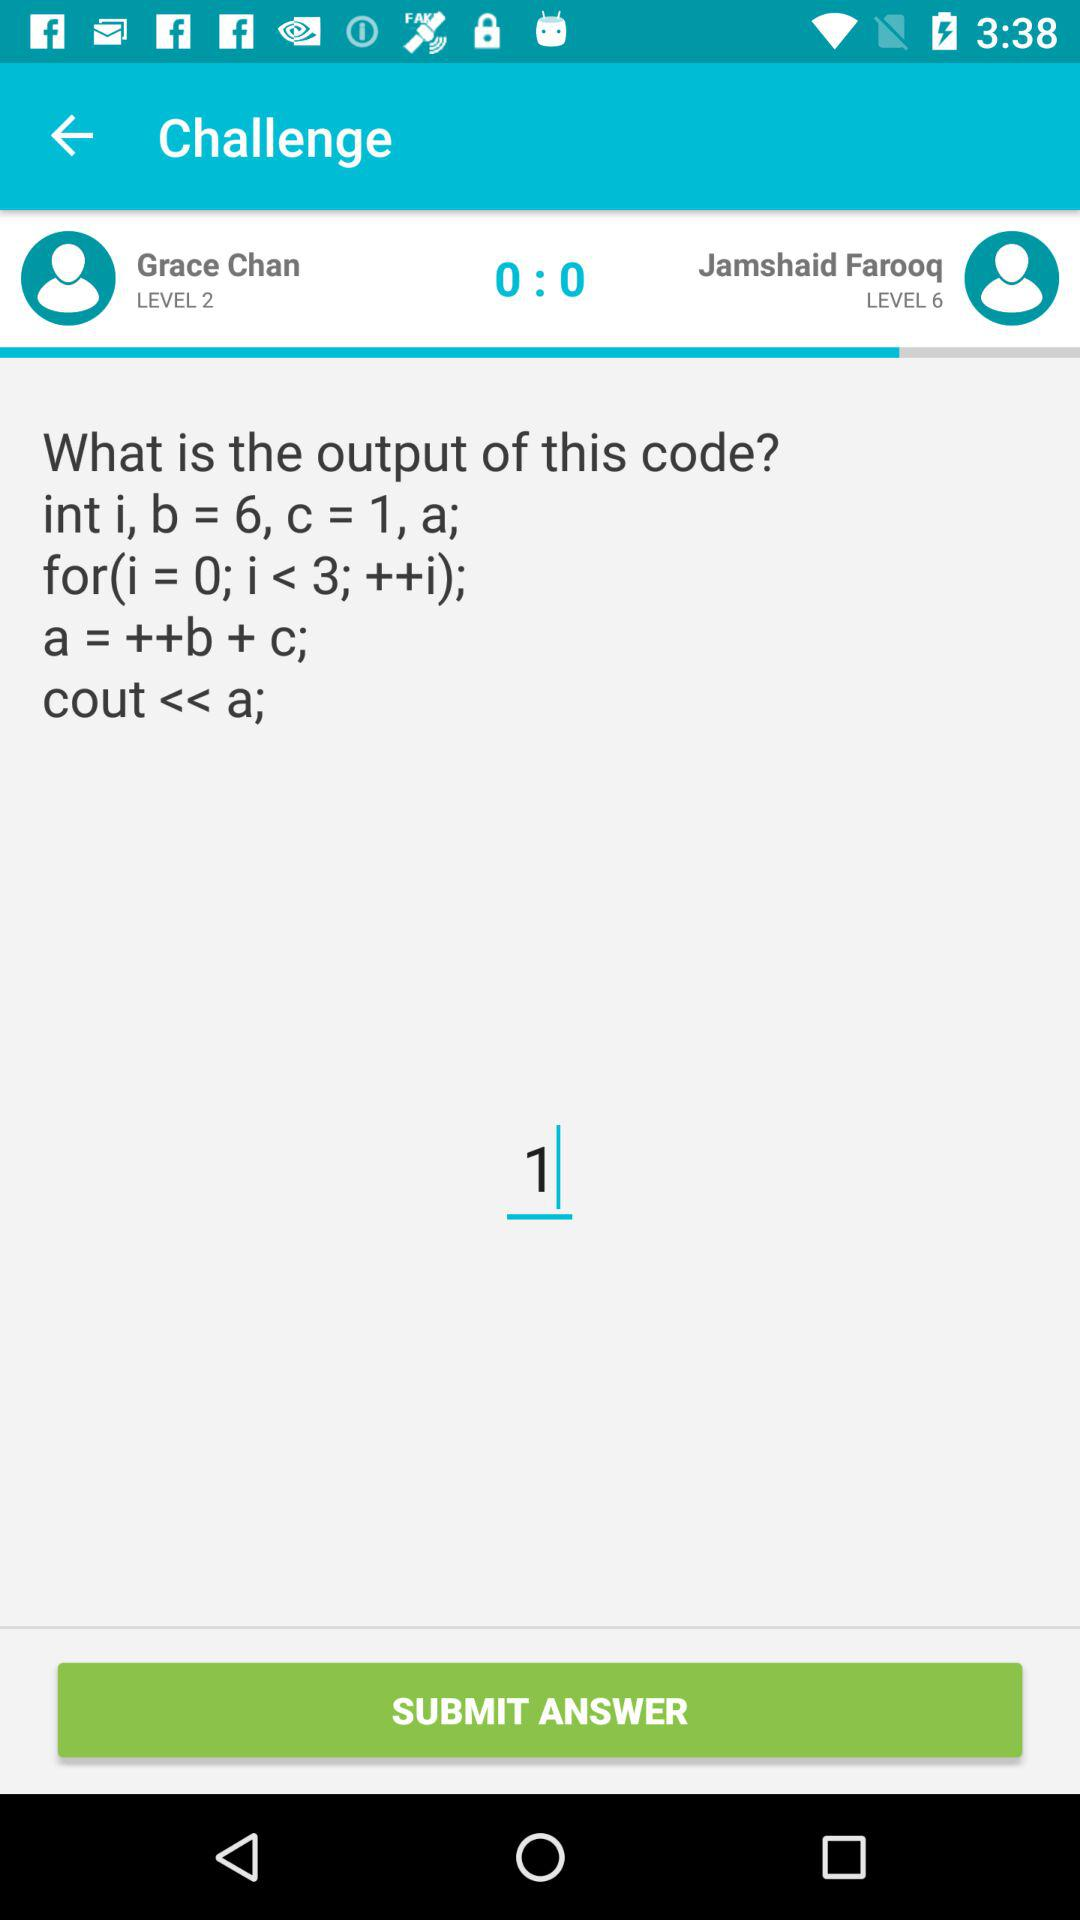What is the score ratio between the two individuals? The score ratio between the two individuals is 0:0. 